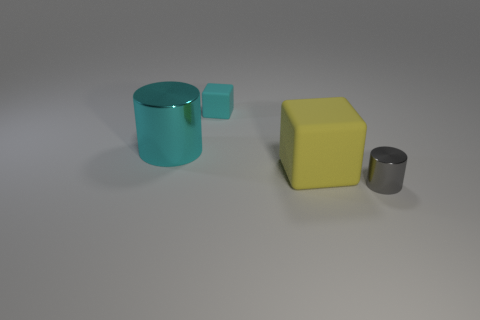What number of big cylinders have the same color as the small cube?
Your answer should be very brief. 1. Is the tiny matte cube the same color as the big shiny thing?
Ensure brevity in your answer.  Yes. What is the material of the cyan thing that is in front of the small cyan thing?
Your answer should be very brief. Metal. There is a object that is the same color as the tiny rubber block; what is its material?
Offer a terse response. Metal. There is a rubber cube behind the large object on the left side of the rubber object that is behind the yellow rubber cube; what is its size?
Give a very brief answer. Small. There is a tiny cyan object that is the same shape as the large yellow thing; what is its material?
Your answer should be compact. Rubber. Is the number of shiny cylinders left of the tiny cyan cube greater than the number of tiny yellow shiny cylinders?
Give a very brief answer. Yes. Is there any other thing that is the same color as the big shiny cylinder?
Offer a terse response. Yes. The small thing that is the same material as the large cyan cylinder is what shape?
Keep it short and to the point. Cylinder. Do the cylinder that is right of the big metallic thing and the large cylinder have the same material?
Make the answer very short. Yes. 